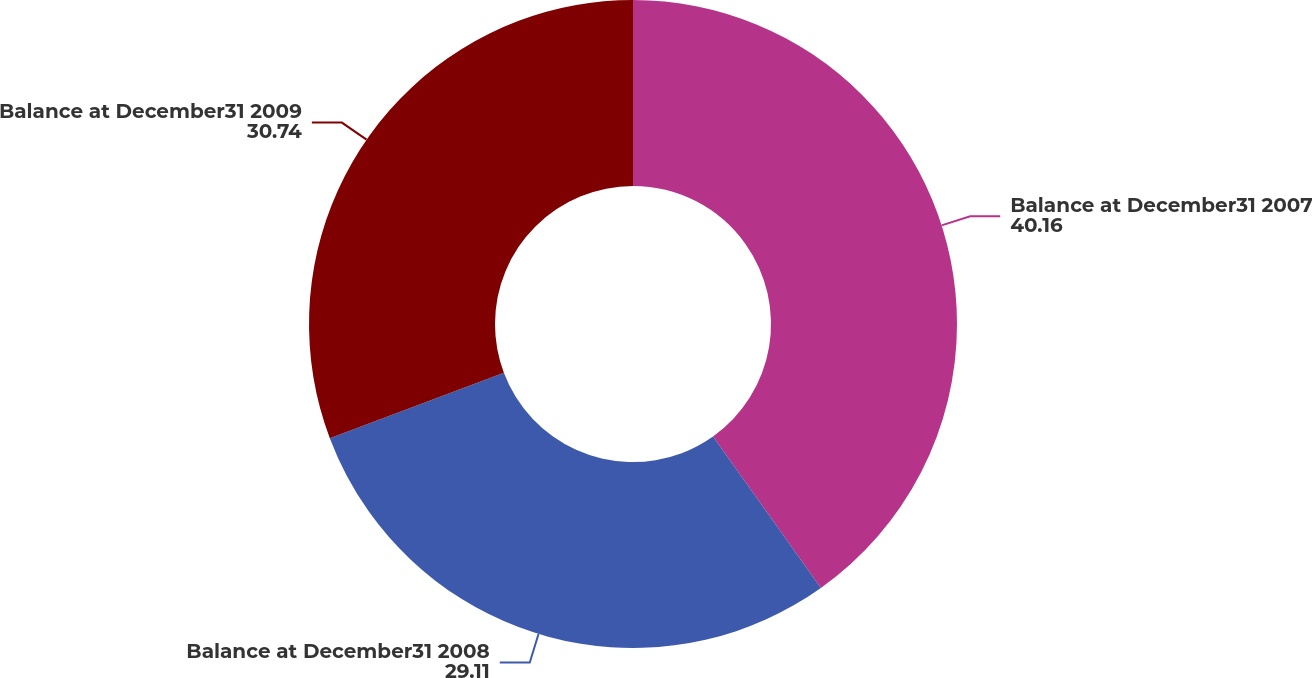Convert chart to OTSL. <chart><loc_0><loc_0><loc_500><loc_500><pie_chart><fcel>Balance at December31 2007<fcel>Balance at December31 2008<fcel>Balance at December31 2009<nl><fcel>40.16%<fcel>29.11%<fcel>30.74%<nl></chart> 